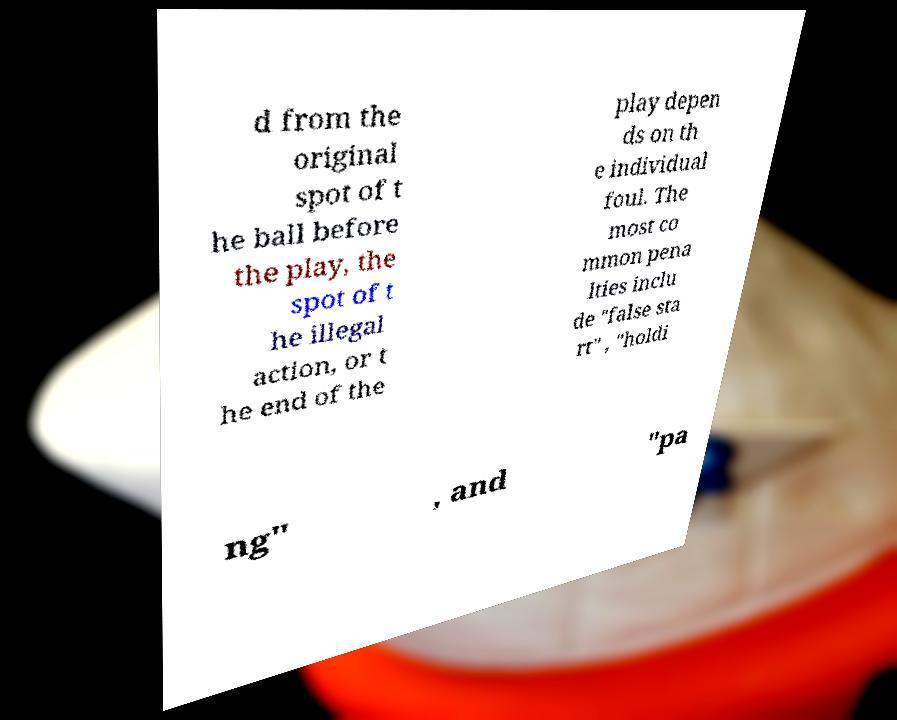Can you accurately transcribe the text from the provided image for me? d from the original spot of t he ball before the play, the spot of t he illegal action, or t he end of the play depen ds on th e individual foul. The most co mmon pena lties inclu de "false sta rt" , "holdi ng" , and "pa 